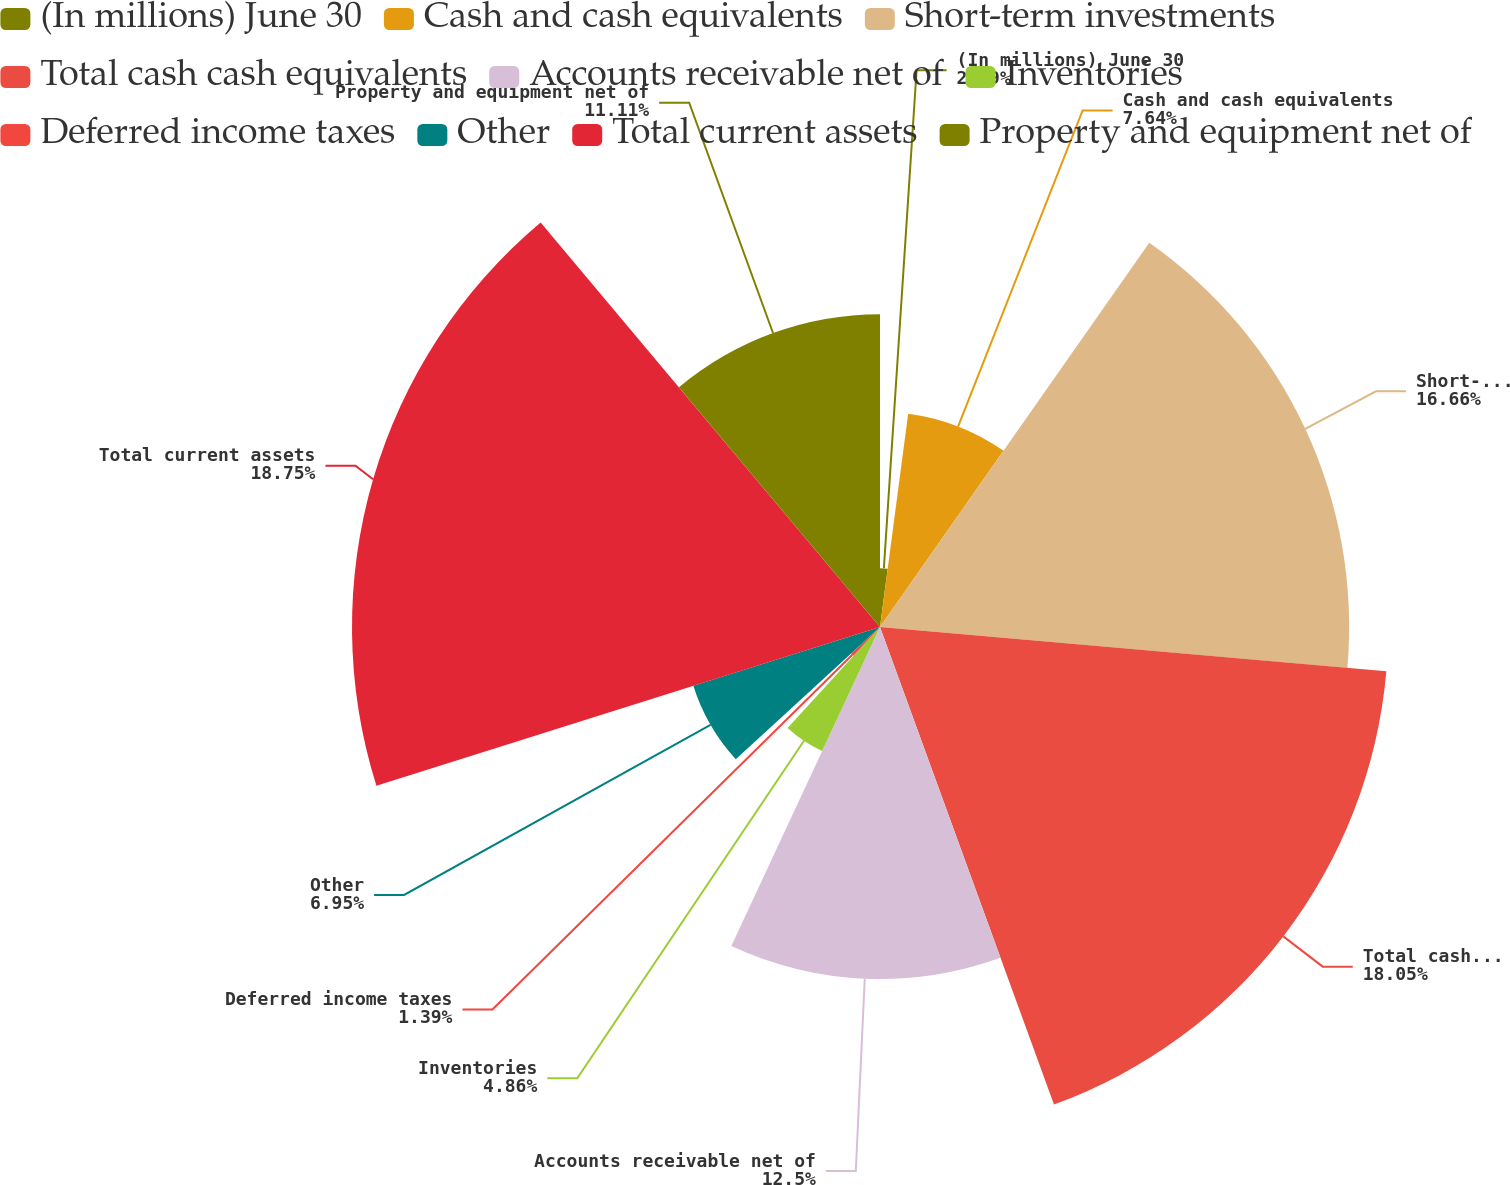Convert chart to OTSL. <chart><loc_0><loc_0><loc_500><loc_500><pie_chart><fcel>(In millions) June 30<fcel>Cash and cash equivalents<fcel>Short-term investments<fcel>Total cash cash equivalents<fcel>Accounts receivable net of<fcel>Inventories<fcel>Deferred income taxes<fcel>Other<fcel>Total current assets<fcel>Property and equipment net of<nl><fcel>2.09%<fcel>7.64%<fcel>16.66%<fcel>18.05%<fcel>12.5%<fcel>4.86%<fcel>1.39%<fcel>6.95%<fcel>18.75%<fcel>11.11%<nl></chart> 